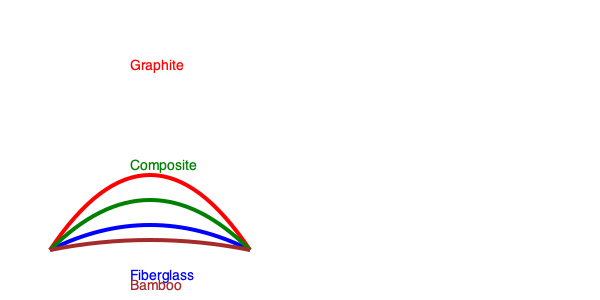Based on the illustrated bent fishing rods, which material offers the highest flexibility, making it ideal for casting lightweight lures and detecting subtle bites? To determine which material offers the highest flexibility, we need to analyze the curvature of each rod in the illustration:

1. Fiberglass (blue): Shows moderate bending, indicating good flexibility.
2. Graphite (red): Displays the most significant bend, suggesting the highest flexibility.
3. Composite (green): Exhibits a bend between fiberglass and graphite, indicating moderate to high flexibility.
4. Bamboo (brown): Shows the least amount of bending, suggesting the lowest flexibility among the four materials.

The degree of bending correlates with the rod's flexibility. A more flexible rod bends more under the same amount of force. Graphite, with its pronounced curve, demonstrates the highest flexibility.

Highly flexible rods are advantageous for:
a) Casting lightweight lures: The rod's ability to load and unload energy efficiently helps in casting light lures farther.
b) Detecting subtle bites: The increased sensitivity allows anglers to feel even the slightest movements transmitted through the line.

Therefore, based on the illustration and the characteristics of flexible rods, graphite offers the highest flexibility, making it ideal for casting lightweight lures and detecting subtle bites.
Answer: Graphite 